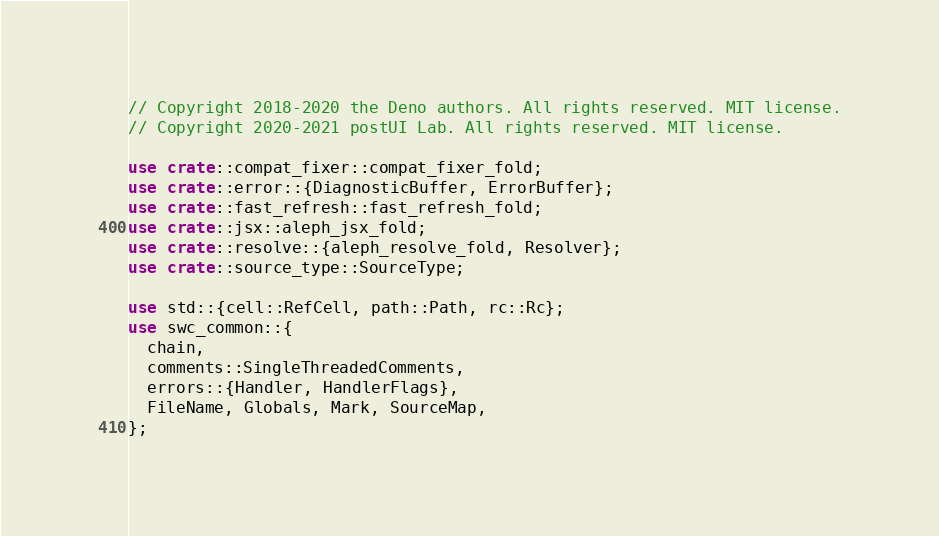Convert code to text. <code><loc_0><loc_0><loc_500><loc_500><_Rust_>// Copyright 2018-2020 the Deno authors. All rights reserved. MIT license.
// Copyright 2020-2021 postUI Lab. All rights reserved. MIT license.

use crate::compat_fixer::compat_fixer_fold;
use crate::error::{DiagnosticBuffer, ErrorBuffer};
use crate::fast_refresh::fast_refresh_fold;
use crate::jsx::aleph_jsx_fold;
use crate::resolve::{aleph_resolve_fold, Resolver};
use crate::source_type::SourceType;

use std::{cell::RefCell, path::Path, rc::Rc};
use swc_common::{
  chain,
  comments::SingleThreadedComments,
  errors::{Handler, HandlerFlags},
  FileName, Globals, Mark, SourceMap,
};</code> 